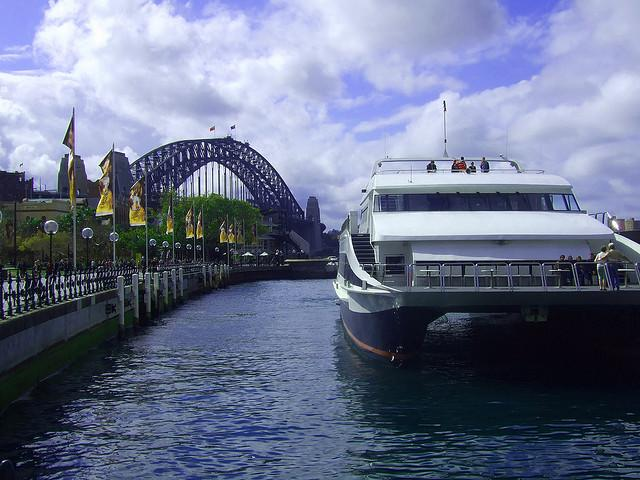Why the gap underneath the boat? aerodynamics 